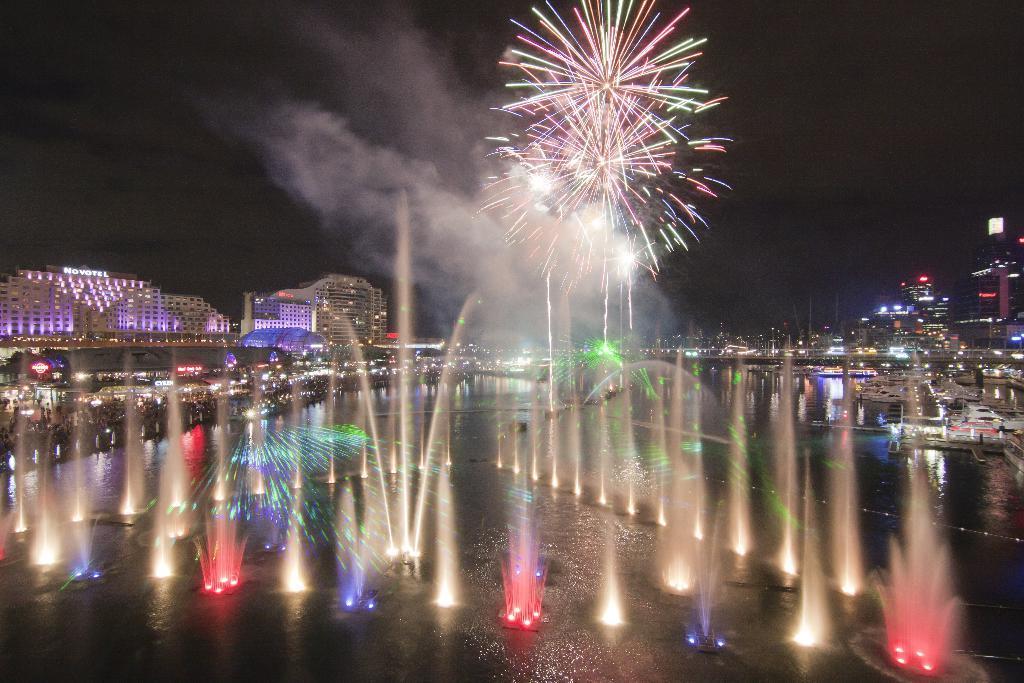Can you describe this image briefly? In this picture I can see the fountains in front and I see the lights and on the right side of this image I see the boats and on the left this image I see the buildings and I see the buildings on the right side top and in the background I see the fireworks in the sky. 